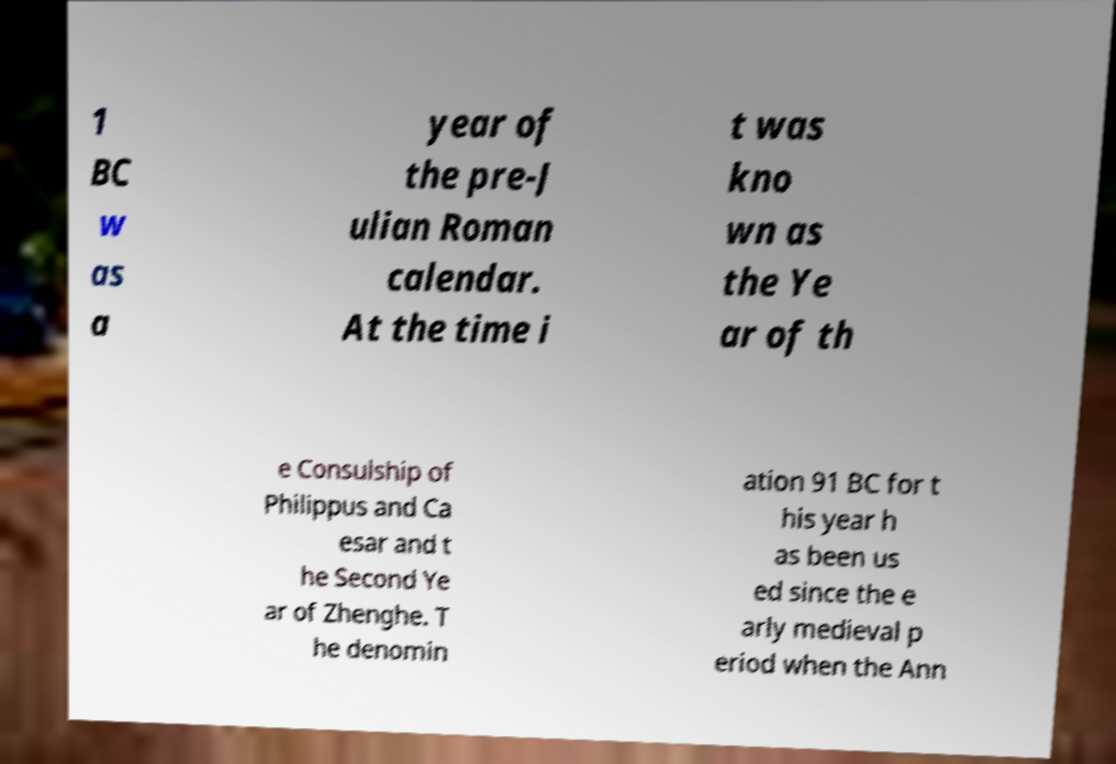Could you extract and type out the text from this image? 1 BC w as a year of the pre-J ulian Roman calendar. At the time i t was kno wn as the Ye ar of th e Consulship of Philippus and Ca esar and t he Second Ye ar of Zhenghe. T he denomin ation 91 BC for t his year h as been us ed since the e arly medieval p eriod when the Ann 